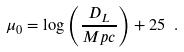<formula> <loc_0><loc_0><loc_500><loc_500>\mu _ { 0 } = \log \left ( \frac { D _ { L } } { M p c } \right ) + 2 5 \ .</formula> 